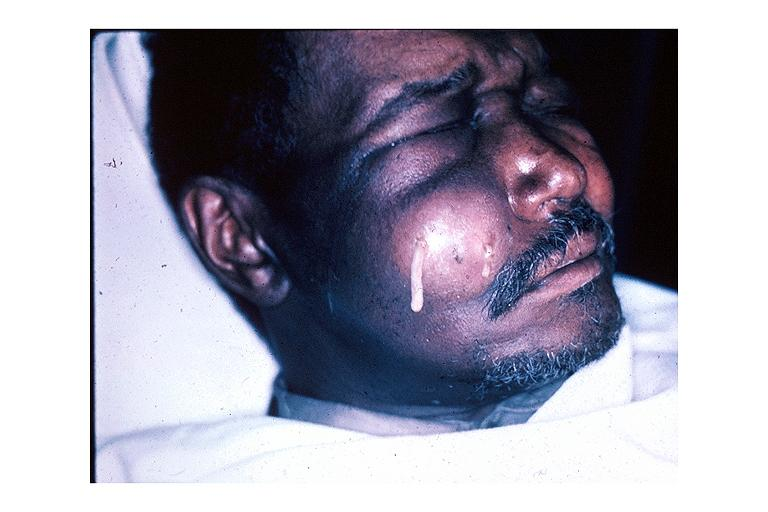what is present?
Answer the question using a single word or phrase. Oral 